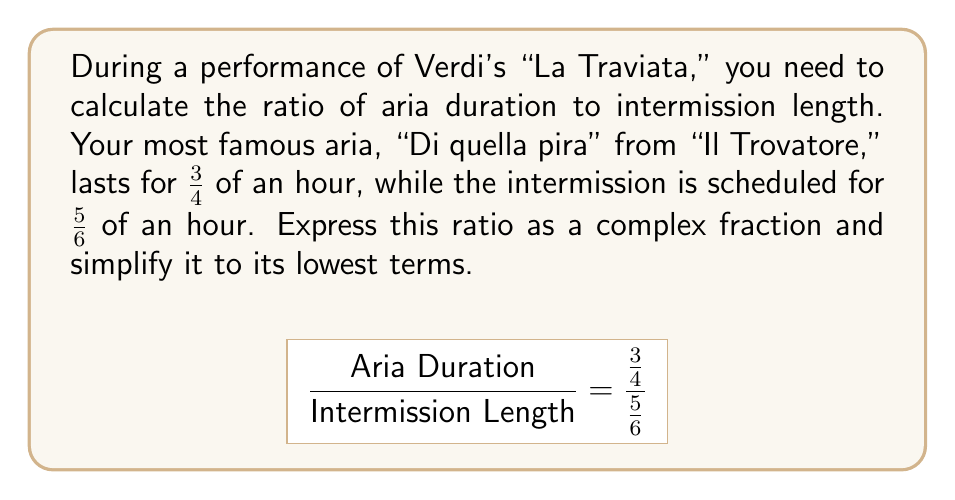Teach me how to tackle this problem. To simplify this complex fraction, we can follow these steps:

1) First, recall that dividing fractions is equivalent to multiplying by the reciprocal. So we can rewrite our fraction as:

   $$\frac{\frac{3}{4}}{\frac{5}{6}} = \frac{3}{4} \cdot \frac{6}{5}$$

2) Now we can multiply the numerators and denominators:

   $$\frac{3}{4} \cdot \frac{6}{5} = \frac{3 \cdot 6}{4 \cdot 5} = \frac{18}{20}$$

3) To simplify this fraction, we need to find the greatest common divisor (GCD) of 18 and 20:
   
   GCD(18, 20) = 2

4) Divide both the numerator and denominator by 2:

   $$\frac{18 \div 2}{20 \div 2} = \frac{9}{10}$$

Thus, the ratio of aria duration to intermission length, simplified to its lowest terms, is $\frac{9}{10}$.
Answer: $\frac{9}{10}$ 